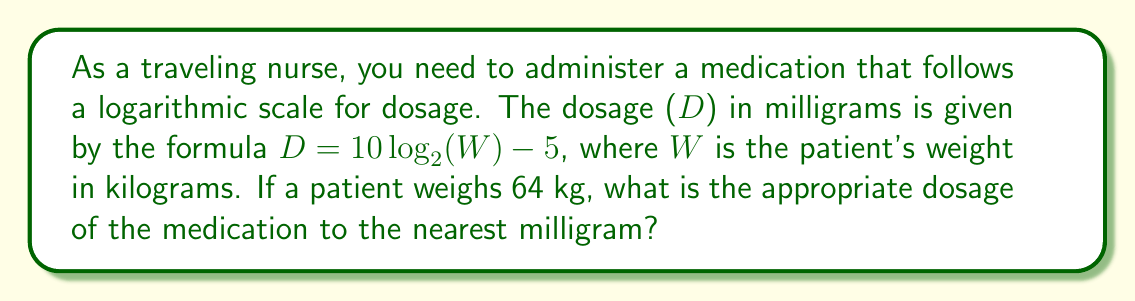Solve this math problem. Let's solve this problem step by step:

1) We are given the formula: $D = 10 \log_{2}(W) - 5$

2) We know that the patient's weight (W) is 64 kg.

3) Let's substitute W = 64 into the formula:
   $D = 10 \log_{2}(64) - 5$

4) Now, we need to calculate $\log_{2}(64)$:
   $2^6 = 64$, so $\log_{2}(64) = 6$

5) Let's substitute this value:
   $D = 10(6) - 5$

6) Now we can perform the arithmetic:
   $D = 60 - 5 = 55$

7) The question asks for the answer to the nearest milligram, but our result is already a whole number, so no rounding is necessary.

Therefore, the appropriate dosage is 55 mg.
Answer: 55 mg 